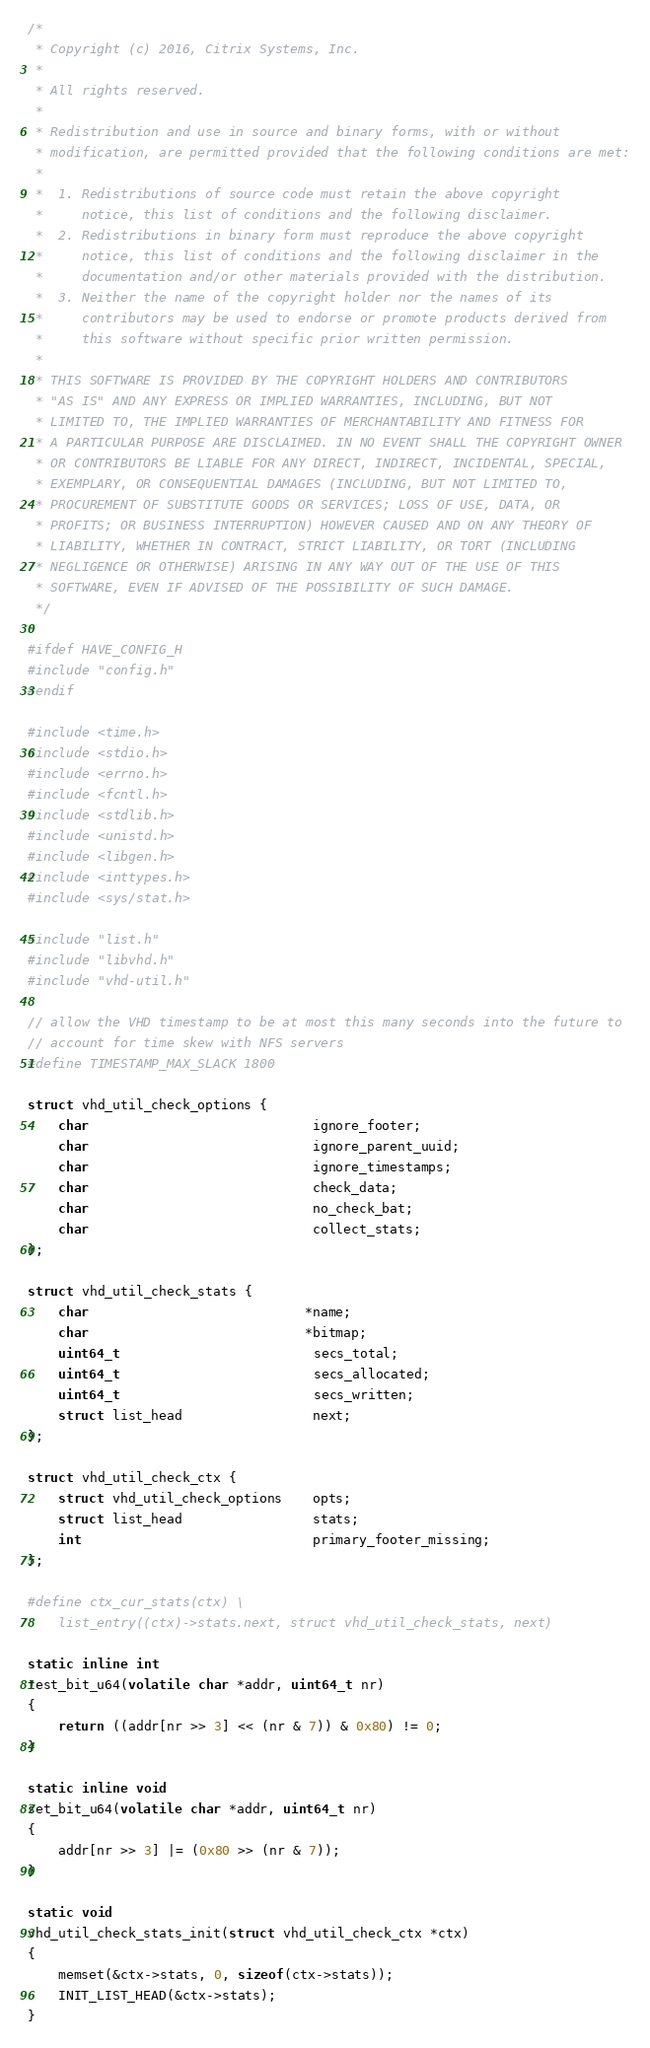<code> <loc_0><loc_0><loc_500><loc_500><_C_>/*
 * Copyright (c) 2016, Citrix Systems, Inc.
 *
 * All rights reserved.
 *
 * Redistribution and use in source and binary forms, with or without
 * modification, are permitted provided that the following conditions are met:
 * 
 *  1. Redistributions of source code must retain the above copyright
 *     notice, this list of conditions and the following disclaimer.
 *  2. Redistributions in binary form must reproduce the above copyright
 *     notice, this list of conditions and the following disclaimer in the
 *     documentation and/or other materials provided with the distribution.
 *  3. Neither the name of the copyright holder nor the names of its 
 *     contributors may be used to endorse or promote products derived from 
 *     this software without specific prior written permission.
 *
 * THIS SOFTWARE IS PROVIDED BY THE COPYRIGHT HOLDERS AND CONTRIBUTORS
 * "AS IS" AND ANY EXPRESS OR IMPLIED WARRANTIES, INCLUDING, BUT NOT
 * LIMITED TO, THE IMPLIED WARRANTIES OF MERCHANTABILITY AND FITNESS FOR
 * A PARTICULAR PURPOSE ARE DISCLAIMED. IN NO EVENT SHALL THE COPYRIGHT OWNER
 * OR CONTRIBUTORS BE LIABLE FOR ANY DIRECT, INDIRECT, INCIDENTAL, SPECIAL,
 * EXEMPLARY, OR CONSEQUENTIAL DAMAGES (INCLUDING, BUT NOT LIMITED TO,
 * PROCUREMENT OF SUBSTITUTE GOODS OR SERVICES; LOSS OF USE, DATA, OR
 * PROFITS; OR BUSINESS INTERRUPTION) HOWEVER CAUSED AND ON ANY THEORY OF
 * LIABILITY, WHETHER IN CONTRACT, STRICT LIABILITY, OR TORT (INCLUDING
 * NEGLIGENCE OR OTHERWISE) ARISING IN ANY WAY OUT OF THE USE OF THIS
 * SOFTWARE, EVEN IF ADVISED OF THE POSSIBILITY OF SUCH DAMAGE.
 */

#ifdef HAVE_CONFIG_H
#include "config.h"
#endif

#include <time.h>
#include <stdio.h>
#include <errno.h>
#include <fcntl.h>
#include <stdlib.h>
#include <unistd.h>
#include <libgen.h>
#include <inttypes.h>
#include <sys/stat.h>

#include "list.h"
#include "libvhd.h"
#include "vhd-util.h"

// allow the VHD timestamp to be at most this many seconds into the future to 
// account for time skew with NFS servers
#define TIMESTAMP_MAX_SLACK 1800

struct vhd_util_check_options {
	char                             ignore_footer;
	char                             ignore_parent_uuid;
	char                             ignore_timestamps;
	char                             check_data;
	char                             no_check_bat;
	char                             collect_stats;
};

struct vhd_util_check_stats {
	char                            *name;
	char                            *bitmap;
	uint64_t                         secs_total;
	uint64_t                         secs_allocated;
	uint64_t                         secs_written;
	struct list_head                 next;
};

struct vhd_util_check_ctx {
	struct vhd_util_check_options    opts;
	struct list_head                 stats;
	int                              primary_footer_missing;
};

#define ctx_cur_stats(ctx) \
	list_entry((ctx)->stats.next, struct vhd_util_check_stats, next)

static inline int
test_bit_u64(volatile char *addr, uint64_t nr)
{
	return ((addr[nr >> 3] << (nr & 7)) & 0x80) != 0;
}

static inline void
set_bit_u64(volatile char *addr, uint64_t nr)
{
	addr[nr >> 3] |= (0x80 >> (nr & 7));
}

static void
vhd_util_check_stats_init(struct vhd_util_check_ctx *ctx)
{
	memset(&ctx->stats, 0, sizeof(ctx->stats));
	INIT_LIST_HEAD(&ctx->stats);
}
</code> 